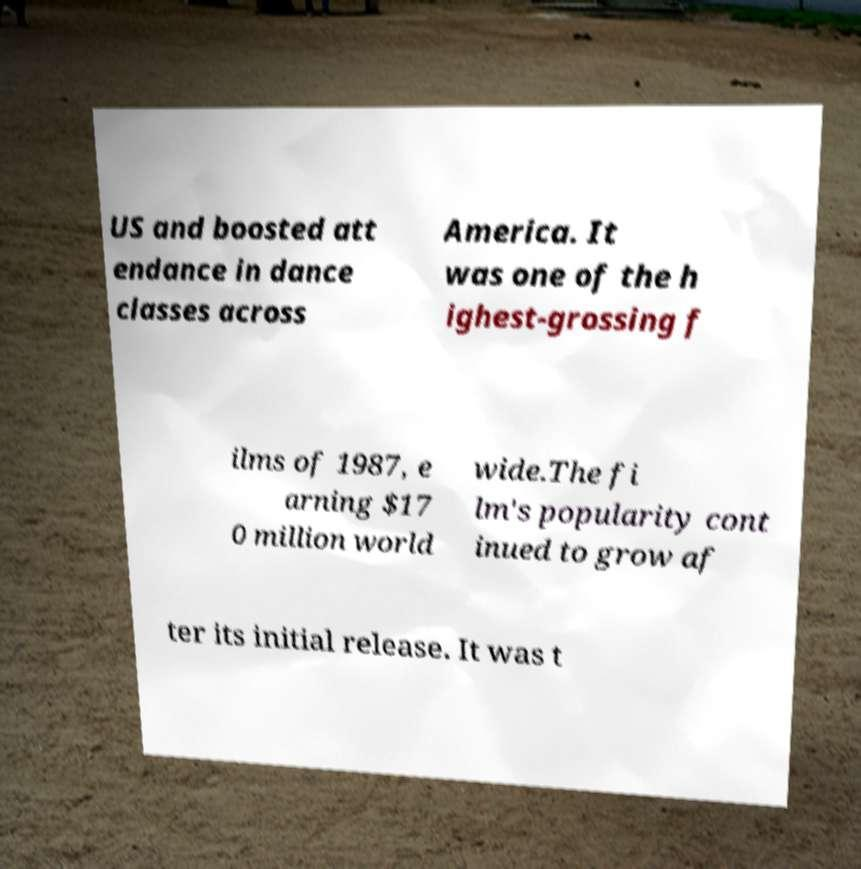Could you extract and type out the text from this image? US and boosted att endance in dance classes across America. It was one of the h ighest-grossing f ilms of 1987, e arning $17 0 million world wide.The fi lm's popularity cont inued to grow af ter its initial release. It was t 